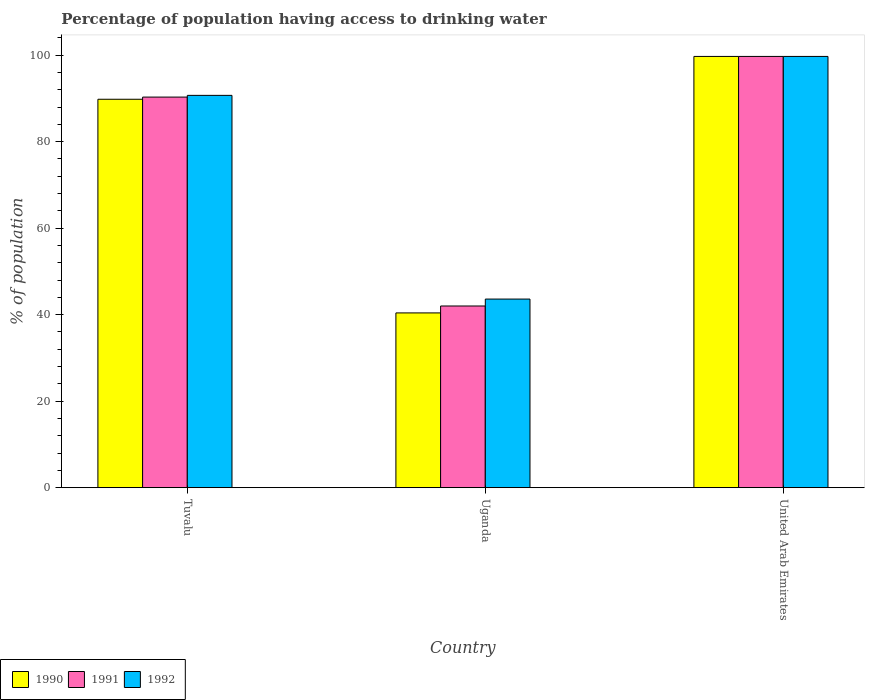How many groups of bars are there?
Keep it short and to the point. 3. How many bars are there on the 2nd tick from the left?
Give a very brief answer. 3. What is the label of the 3rd group of bars from the left?
Your answer should be very brief. United Arab Emirates. Across all countries, what is the maximum percentage of population having access to drinking water in 1992?
Your response must be concise. 99.7. Across all countries, what is the minimum percentage of population having access to drinking water in 1992?
Provide a short and direct response. 43.6. In which country was the percentage of population having access to drinking water in 1991 maximum?
Offer a terse response. United Arab Emirates. In which country was the percentage of population having access to drinking water in 1992 minimum?
Your answer should be compact. Uganda. What is the total percentage of population having access to drinking water in 1991 in the graph?
Your answer should be compact. 232. What is the difference between the percentage of population having access to drinking water in 1990 in Uganda and that in United Arab Emirates?
Offer a very short reply. -59.3. What is the difference between the percentage of population having access to drinking water in 1992 in Uganda and the percentage of population having access to drinking water in 1991 in United Arab Emirates?
Your response must be concise. -56.1. What is the average percentage of population having access to drinking water in 1991 per country?
Your answer should be very brief. 77.33. What is the difference between the percentage of population having access to drinking water of/in 1990 and percentage of population having access to drinking water of/in 1991 in Uganda?
Your response must be concise. -1.6. What is the ratio of the percentage of population having access to drinking water in 1992 in Tuvalu to that in United Arab Emirates?
Your answer should be very brief. 0.91. What is the difference between the highest and the second highest percentage of population having access to drinking water in 1991?
Your response must be concise. -9.4. What is the difference between the highest and the lowest percentage of population having access to drinking water in 1991?
Make the answer very short. 57.7. In how many countries, is the percentage of population having access to drinking water in 1992 greater than the average percentage of population having access to drinking water in 1992 taken over all countries?
Give a very brief answer. 2. What does the 2nd bar from the left in United Arab Emirates represents?
Keep it short and to the point. 1991. How many bars are there?
Make the answer very short. 9. What is the difference between two consecutive major ticks on the Y-axis?
Offer a very short reply. 20. Are the values on the major ticks of Y-axis written in scientific E-notation?
Provide a short and direct response. No. Where does the legend appear in the graph?
Provide a short and direct response. Bottom left. How are the legend labels stacked?
Keep it short and to the point. Horizontal. What is the title of the graph?
Offer a very short reply. Percentage of population having access to drinking water. Does "2004" appear as one of the legend labels in the graph?
Your response must be concise. No. What is the label or title of the X-axis?
Provide a succinct answer. Country. What is the label or title of the Y-axis?
Give a very brief answer. % of population. What is the % of population in 1990 in Tuvalu?
Provide a short and direct response. 89.8. What is the % of population in 1991 in Tuvalu?
Keep it short and to the point. 90.3. What is the % of population of 1992 in Tuvalu?
Make the answer very short. 90.7. What is the % of population of 1990 in Uganda?
Your answer should be very brief. 40.4. What is the % of population in 1991 in Uganda?
Provide a succinct answer. 42. What is the % of population in 1992 in Uganda?
Provide a short and direct response. 43.6. What is the % of population in 1990 in United Arab Emirates?
Make the answer very short. 99.7. What is the % of population in 1991 in United Arab Emirates?
Make the answer very short. 99.7. What is the % of population in 1992 in United Arab Emirates?
Offer a very short reply. 99.7. Across all countries, what is the maximum % of population of 1990?
Your response must be concise. 99.7. Across all countries, what is the maximum % of population of 1991?
Make the answer very short. 99.7. Across all countries, what is the maximum % of population in 1992?
Offer a terse response. 99.7. Across all countries, what is the minimum % of population in 1990?
Your answer should be very brief. 40.4. Across all countries, what is the minimum % of population of 1991?
Keep it short and to the point. 42. Across all countries, what is the minimum % of population of 1992?
Offer a terse response. 43.6. What is the total % of population in 1990 in the graph?
Your answer should be compact. 229.9. What is the total % of population in 1991 in the graph?
Your answer should be very brief. 232. What is the total % of population of 1992 in the graph?
Offer a very short reply. 234. What is the difference between the % of population in 1990 in Tuvalu and that in Uganda?
Your answer should be compact. 49.4. What is the difference between the % of population in 1991 in Tuvalu and that in Uganda?
Your answer should be compact. 48.3. What is the difference between the % of population of 1992 in Tuvalu and that in Uganda?
Offer a very short reply. 47.1. What is the difference between the % of population of 1991 in Tuvalu and that in United Arab Emirates?
Offer a very short reply. -9.4. What is the difference between the % of population in 1990 in Uganda and that in United Arab Emirates?
Offer a terse response. -59.3. What is the difference between the % of population in 1991 in Uganda and that in United Arab Emirates?
Make the answer very short. -57.7. What is the difference between the % of population in 1992 in Uganda and that in United Arab Emirates?
Your answer should be very brief. -56.1. What is the difference between the % of population in 1990 in Tuvalu and the % of population in 1991 in Uganda?
Make the answer very short. 47.8. What is the difference between the % of population in 1990 in Tuvalu and the % of population in 1992 in Uganda?
Your answer should be very brief. 46.2. What is the difference between the % of population in 1991 in Tuvalu and the % of population in 1992 in Uganda?
Your response must be concise. 46.7. What is the difference between the % of population of 1990 in Tuvalu and the % of population of 1991 in United Arab Emirates?
Your response must be concise. -9.9. What is the difference between the % of population of 1990 in Uganda and the % of population of 1991 in United Arab Emirates?
Provide a short and direct response. -59.3. What is the difference between the % of population of 1990 in Uganda and the % of population of 1992 in United Arab Emirates?
Ensure brevity in your answer.  -59.3. What is the difference between the % of population in 1991 in Uganda and the % of population in 1992 in United Arab Emirates?
Offer a very short reply. -57.7. What is the average % of population in 1990 per country?
Make the answer very short. 76.63. What is the average % of population of 1991 per country?
Offer a terse response. 77.33. What is the average % of population of 1992 per country?
Make the answer very short. 78. What is the difference between the % of population in 1991 and % of population in 1992 in Uganda?
Offer a terse response. -1.6. What is the difference between the % of population in 1990 and % of population in 1991 in United Arab Emirates?
Provide a succinct answer. 0. What is the difference between the % of population in 1991 and % of population in 1992 in United Arab Emirates?
Your answer should be compact. 0. What is the ratio of the % of population in 1990 in Tuvalu to that in Uganda?
Your answer should be very brief. 2.22. What is the ratio of the % of population of 1991 in Tuvalu to that in Uganda?
Make the answer very short. 2.15. What is the ratio of the % of population of 1992 in Tuvalu to that in Uganda?
Provide a succinct answer. 2.08. What is the ratio of the % of population of 1990 in Tuvalu to that in United Arab Emirates?
Make the answer very short. 0.9. What is the ratio of the % of population in 1991 in Tuvalu to that in United Arab Emirates?
Provide a short and direct response. 0.91. What is the ratio of the % of population of 1992 in Tuvalu to that in United Arab Emirates?
Your response must be concise. 0.91. What is the ratio of the % of population of 1990 in Uganda to that in United Arab Emirates?
Give a very brief answer. 0.41. What is the ratio of the % of population of 1991 in Uganda to that in United Arab Emirates?
Give a very brief answer. 0.42. What is the ratio of the % of population of 1992 in Uganda to that in United Arab Emirates?
Make the answer very short. 0.44. What is the difference between the highest and the second highest % of population in 1991?
Offer a very short reply. 9.4. What is the difference between the highest and the second highest % of population of 1992?
Your answer should be very brief. 9. What is the difference between the highest and the lowest % of population of 1990?
Ensure brevity in your answer.  59.3. What is the difference between the highest and the lowest % of population of 1991?
Provide a short and direct response. 57.7. What is the difference between the highest and the lowest % of population of 1992?
Make the answer very short. 56.1. 